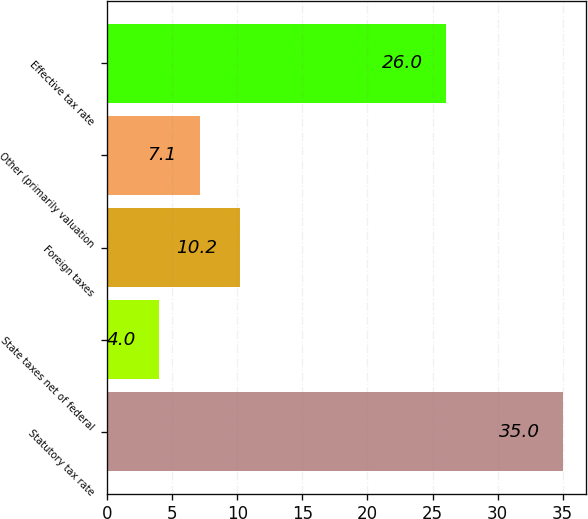<chart> <loc_0><loc_0><loc_500><loc_500><bar_chart><fcel>Statutory tax rate<fcel>State taxes net of federal<fcel>Foreign taxes<fcel>Other (primarily valuation<fcel>Effective tax rate<nl><fcel>35<fcel>4<fcel>10.2<fcel>7.1<fcel>26<nl></chart> 